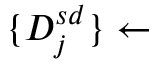<formula> <loc_0><loc_0><loc_500><loc_500>\{ D _ { j } ^ { s d } \} \leftarrow</formula> 